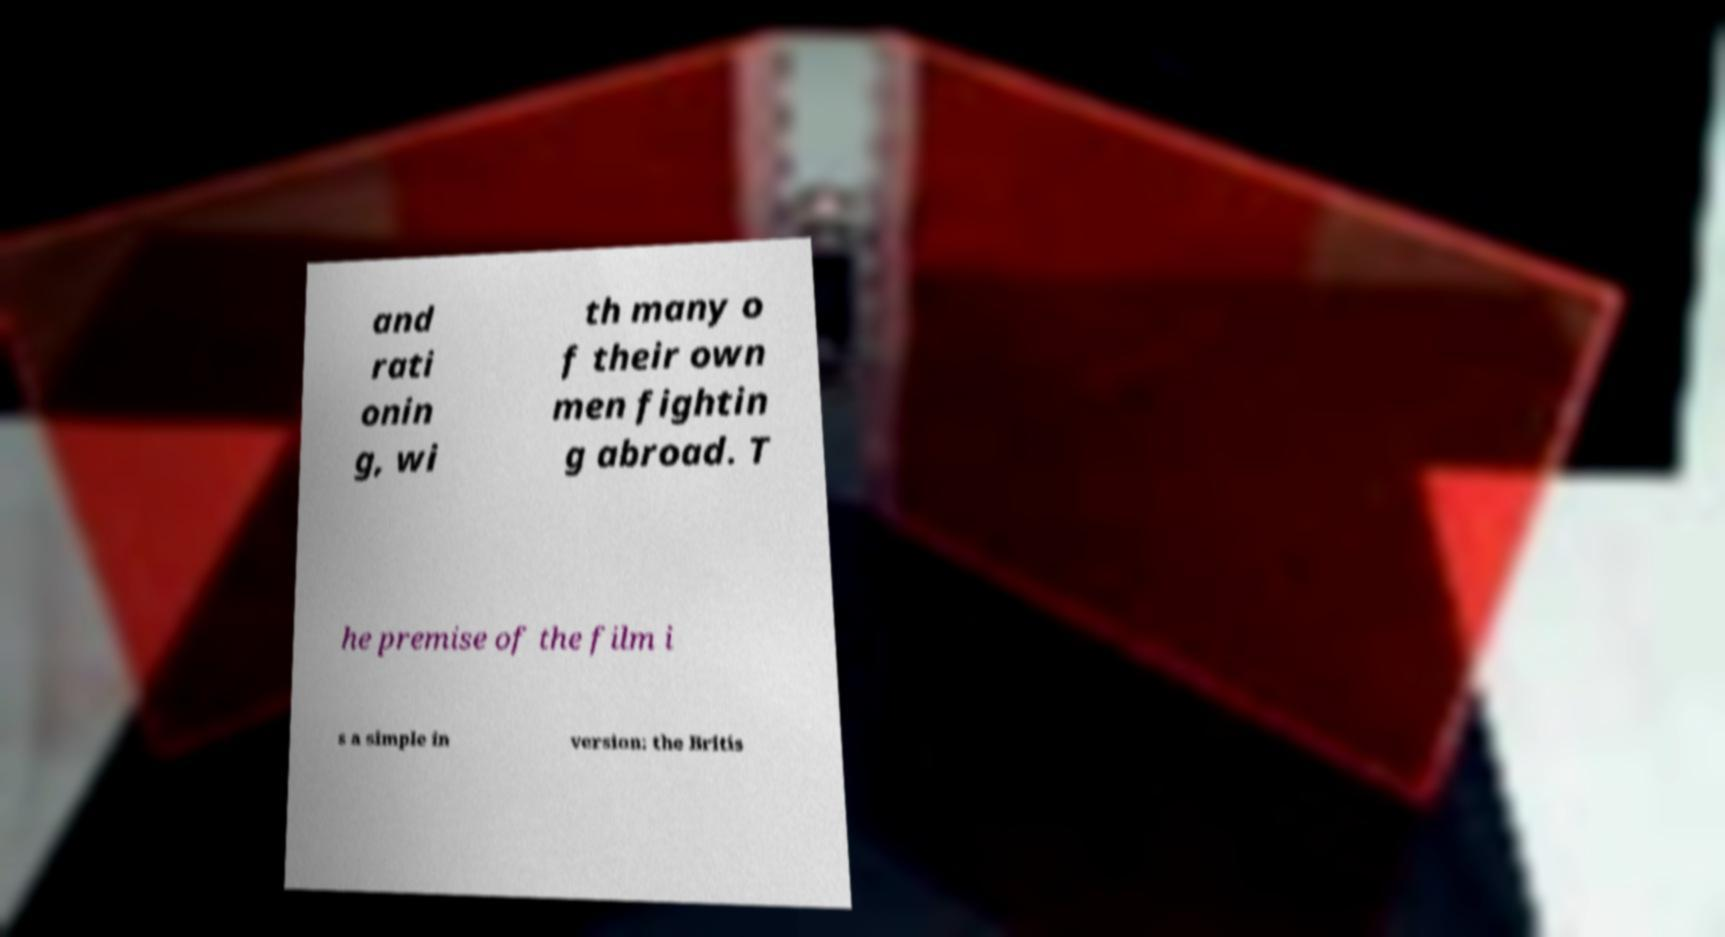There's text embedded in this image that I need extracted. Can you transcribe it verbatim? and rati onin g, wi th many o f their own men fightin g abroad. T he premise of the film i s a simple in version: the Britis 